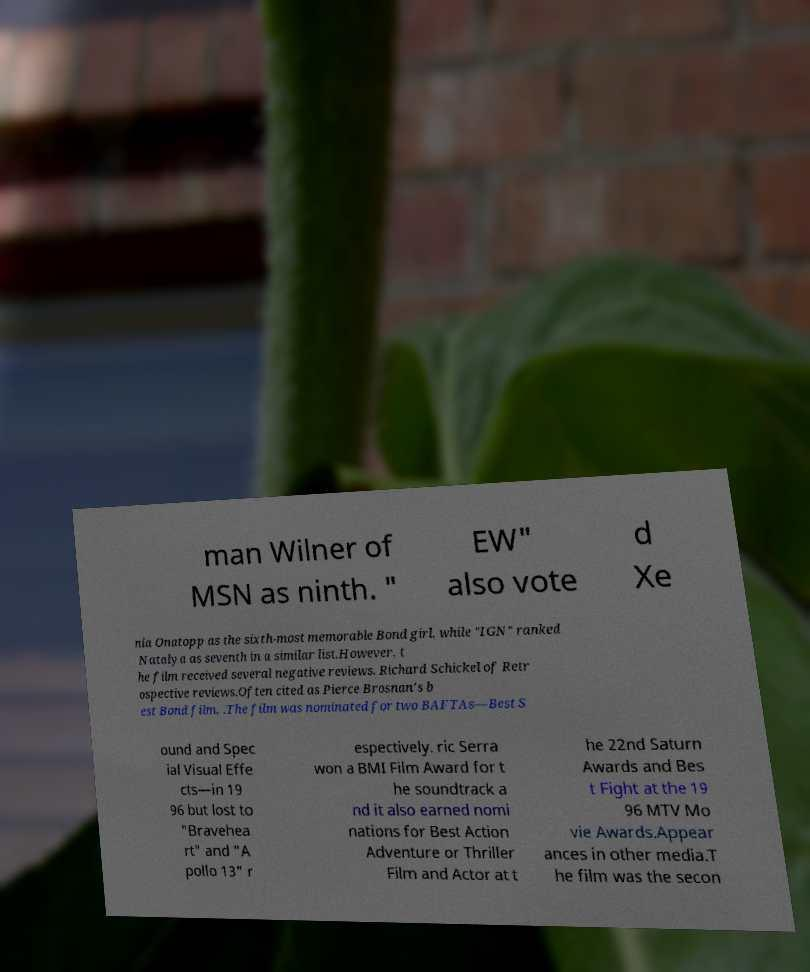For documentation purposes, I need the text within this image transcribed. Could you provide that? man Wilner of MSN as ninth. " EW" also vote d Xe nia Onatopp as the sixth-most memorable Bond girl, while "IGN" ranked Natalya as seventh in a similar list.However, t he film received several negative reviews. Richard Schickel of Retr ospective reviews.Often cited as Pierce Brosnan's b est Bond film, .The film was nominated for two BAFTAs—Best S ound and Spec ial Visual Effe cts—in 19 96 but lost to "Bravehea rt" and "A pollo 13" r espectively. ric Serra won a BMI Film Award for t he soundtrack a nd it also earned nomi nations for Best Action Adventure or Thriller Film and Actor at t he 22nd Saturn Awards and Bes t Fight at the 19 96 MTV Mo vie Awards.Appear ances in other media.T he film was the secon 